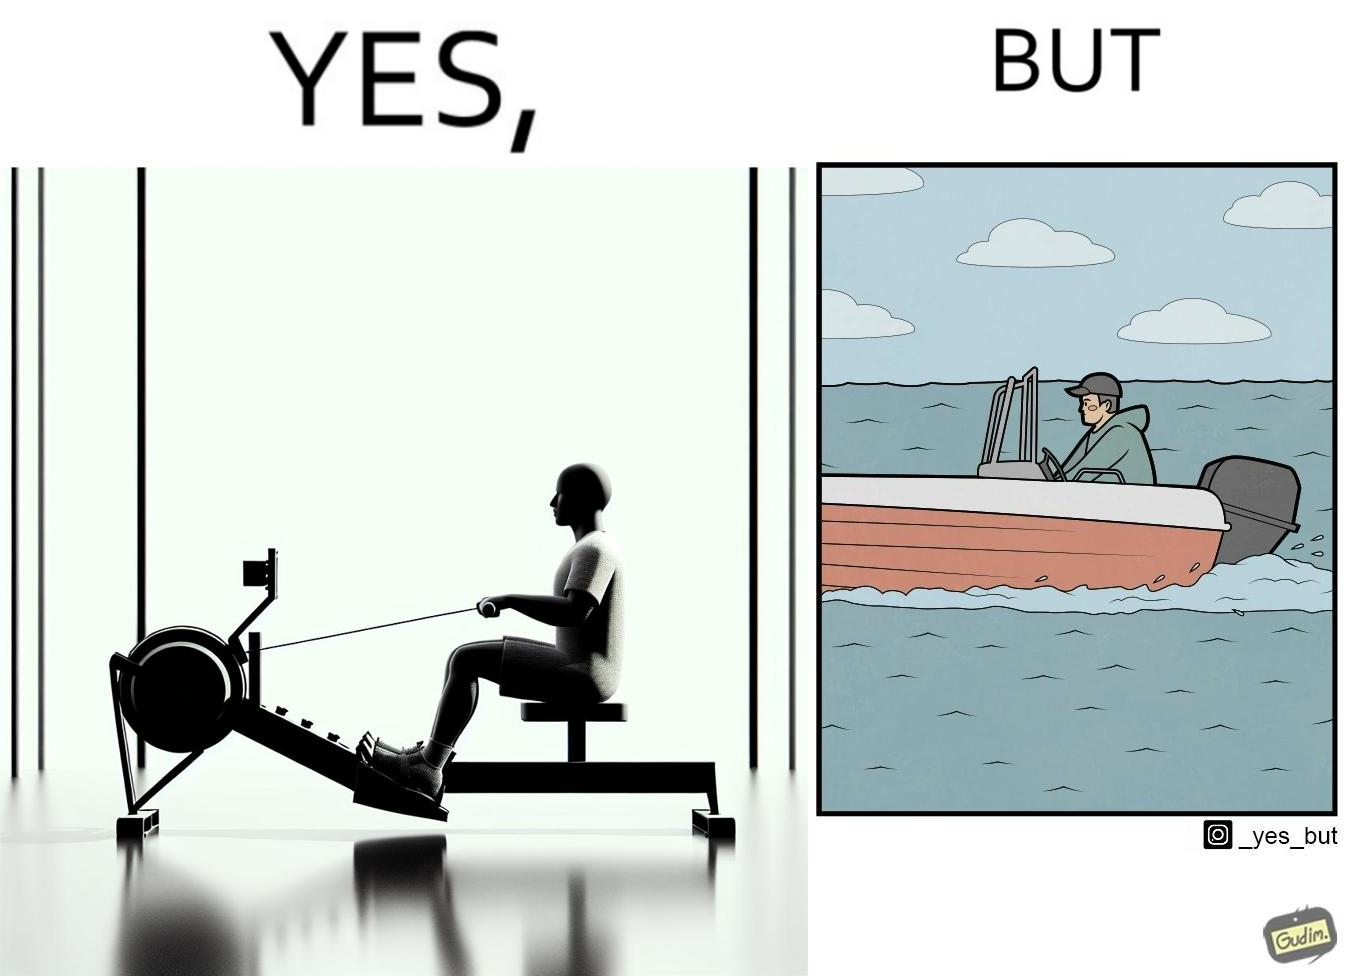Would you classify this image as satirical? Yes, this image is satirical. 